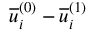<formula> <loc_0><loc_0><loc_500><loc_500>\overline { u } _ { i } ^ { ( 0 ) } - \overline { u } _ { i } ^ { ( 1 ) }</formula> 